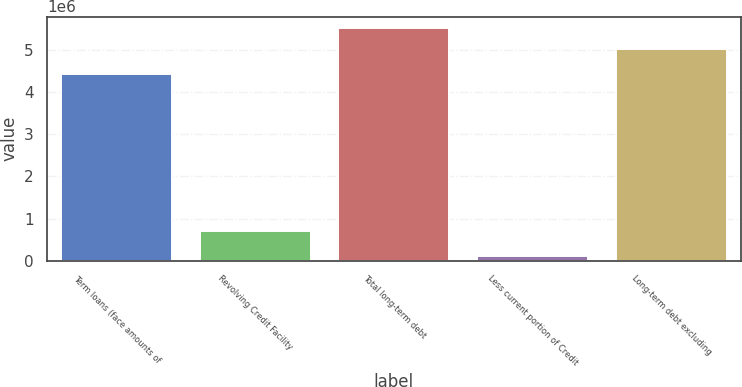<chart> <loc_0><loc_0><loc_500><loc_500><bar_chart><fcel>Term loans (face amounts of<fcel>Revolving Credit Facility<fcel>Total long-term debt<fcel>Less current portion of Credit<fcel>Long-term debt excluding<nl><fcel>4.42624e+06<fcel>704000<fcel>5.51668e+06<fcel>115075<fcel>5.01517e+06<nl></chart> 